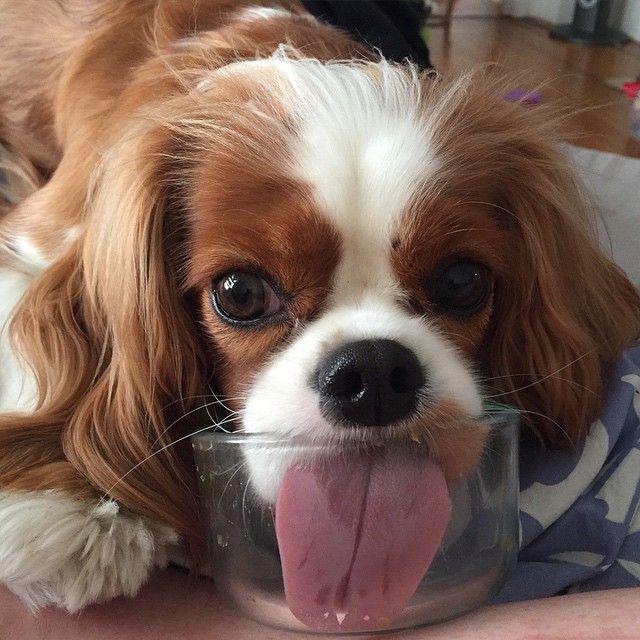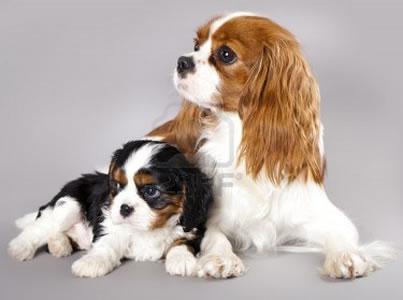The first image is the image on the left, the second image is the image on the right. Considering the images on both sides, is "At least one dog is laying down." valid? Answer yes or no. Yes. 